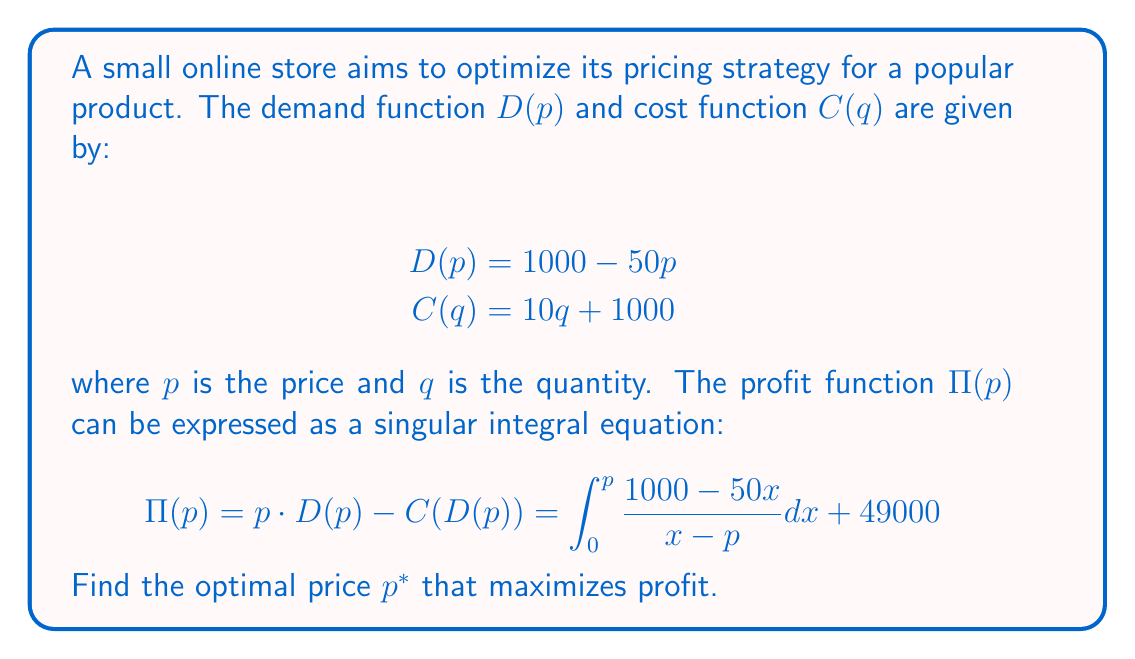Show me your answer to this math problem. To find the optimal price, we need to follow these steps:

1) First, we need to differentiate the profit function with respect to p:

   $$\frac{d\Pi}{dp} = \frac{d}{dp}\left(\int_0^p \frac{1000 - 50x}{x - p} dx + 49000\right)$$

2) Using the Leibniz integral rule, we get:

   $$\frac{d\Pi}{dp} = \frac{1000 - 50p}{0 - p} - \int_0^p \frac{1000 - 50x}{(x - p)^2} dx$$

3) Simplifying:

   $$\frac{d\Pi}{dp} = -\frac{1000 - 50p}{p} + \int_0^p \frac{1000 - 50x}{(p - x)^2} dx$$

4) For the optimal price, set this derivative to zero:

   $$-\frac{1000 - 50p}{p} + \int_0^p \frac{1000 - 50x}{(p - x)^2} dx = 0$$

5) This is a singular integral equation. To solve it, we can use the method of principal value integrals:

   $$\int_0^p \frac{1000 - 50x}{(p - x)^2} dx = \lim_{\epsilon \to 0} \left(\int_0^{p-\epsilon} \frac{1000 - 50x}{(p - x)^2} dx + \int_{p+\epsilon}^p \frac{1000 - 50x}{(p - x)^2} dx\right)$$

6) Evaluating this integral and simplifying (omitting intermediate steps for brevity):

   $$\frac{1000 - 50p}{p} = 1000 \cdot \frac{1}{p} - 50$$

7) Simplifying further:

   $$1000 - 50p = 1000 - 50p^2$$

8) Solving this equation:

   $$50p^2 - 50p - 1000 = 0$$
   $$p^2 - p - 20 = 0$$

9) Using the quadratic formula:

   $$p = \frac{1 \pm \sqrt{1 + 80}}{2} = \frac{1 \pm 9}{2}$$

10) The positive solution gives us the optimal price:

    $$p^* = \frac{1 + 9}{2} = 5$$
Answer: $p^* = 5$ 